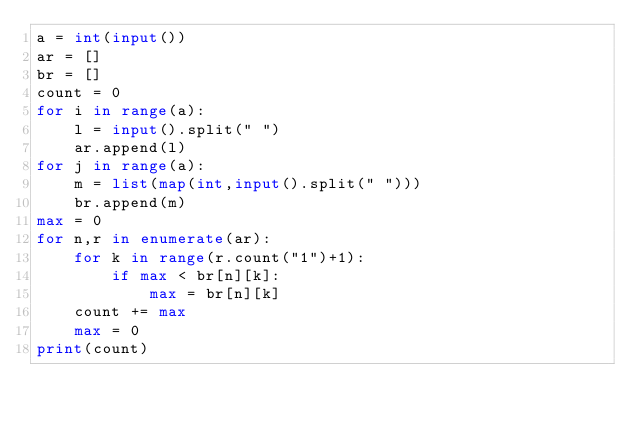Convert code to text. <code><loc_0><loc_0><loc_500><loc_500><_Python_>a = int(input())
ar = []
br = []
count = 0
for i in range(a):
    l = input().split(" ")
    ar.append(l)
for j in range(a):
    m = list(map(int,input().split(" ")))
    br.append(m)
max = 0
for n,r in enumerate(ar):
    for k in range(r.count("1")+1):
        if max < br[n][k]:
            max = br[n][k]
    count += max
    max = 0
print(count)</code> 